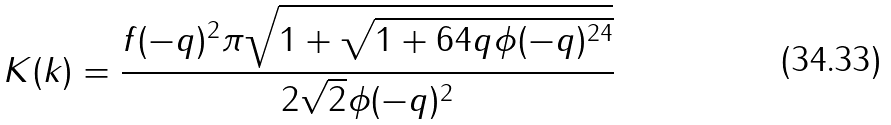<formula> <loc_0><loc_0><loc_500><loc_500>K ( k ) = \frac { f ( - q ) ^ { 2 } \pi \sqrt { 1 + \sqrt { 1 + 6 4 q \phi ( - q ) ^ { 2 4 } } } } { 2 \sqrt { 2 } \phi ( - q ) ^ { 2 } }</formula> 